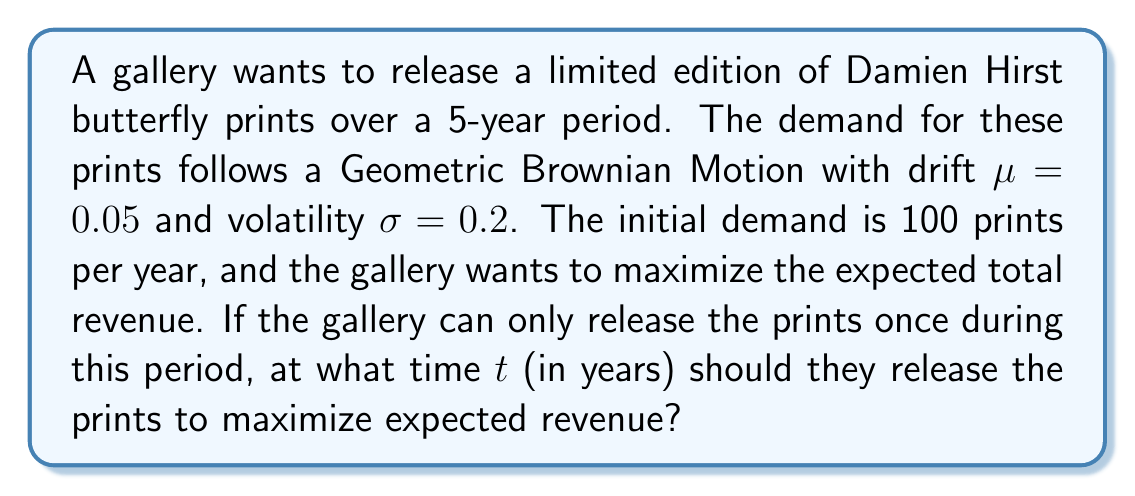Show me your answer to this math problem. To solve this problem, we'll use the principles of stochastic optimization and the properties of Geometric Brownian Motion (GBM).

1) In a GBM, the expected value of the demand at time $t$ is given by:
   $$E[S_t] = S_0 e^{\mu t}$$
   where $S_0$ is the initial demand.

2) Given $S_0 = 100$, $\mu = 0.05$, the expected demand at time $t$ is:
   $$E[S_t] = 100 e^{0.05t}$$

3) To maximize revenue, we need to find the time $t$ that maximizes this function over the 5-year period.

4) The maximum of this function will occur at the end of the period (t = 5) because the exponential function is always increasing when the exponent is positive.

5) We can verify this by taking the derivative:
   $$\frac{d}{dt}E[S_t] = 100 \cdot 0.05 e^{0.05t}$$
   This is always positive for $t \geq 0$, confirming that the function is always increasing.

6) Therefore, the optimal time to release the prints is at $t = 5$ years.

7) The expected demand at this time would be:
   $$E[S_5] = 100 e^{0.05 \cdot 5} \approx 128.4$$

Note: The volatility $\sigma$ doesn't affect the expected value in this case, but it would be relevant if we were considering risk or other probabilistic aspects of the problem.
Answer: 5 years 